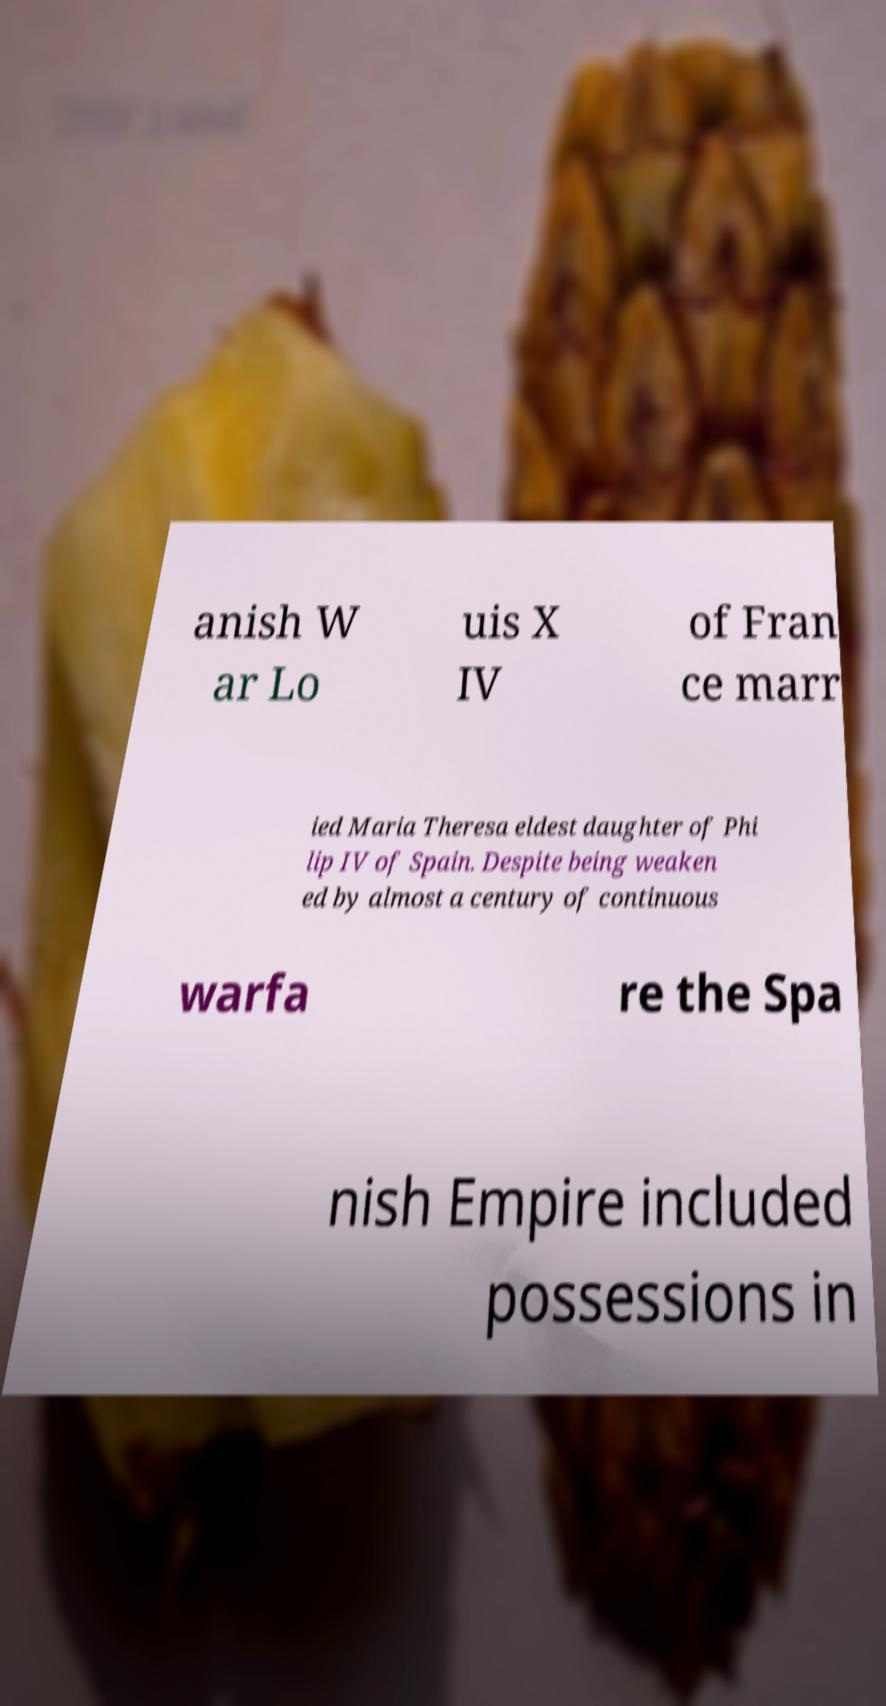Please identify and transcribe the text found in this image. anish W ar Lo uis X IV of Fran ce marr ied Maria Theresa eldest daughter of Phi lip IV of Spain. Despite being weaken ed by almost a century of continuous warfa re the Spa nish Empire included possessions in 